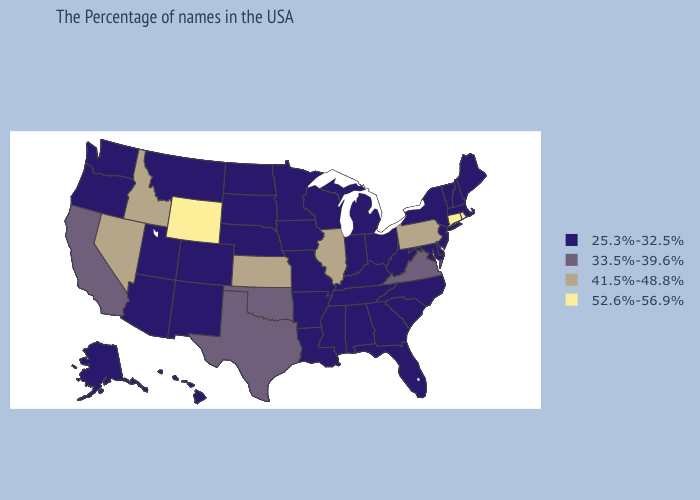Name the states that have a value in the range 25.3%-32.5%?
Give a very brief answer. Maine, Massachusetts, New Hampshire, Vermont, New York, New Jersey, Delaware, Maryland, North Carolina, South Carolina, West Virginia, Ohio, Florida, Georgia, Michigan, Kentucky, Indiana, Alabama, Tennessee, Wisconsin, Mississippi, Louisiana, Missouri, Arkansas, Minnesota, Iowa, Nebraska, South Dakota, North Dakota, Colorado, New Mexico, Utah, Montana, Arizona, Washington, Oregon, Alaska, Hawaii. Does Florida have the lowest value in the South?
Give a very brief answer. Yes. Does New Hampshire have a lower value than Minnesota?
Short answer required. No. Does Ohio have the same value as Illinois?
Keep it brief. No. What is the lowest value in states that border Rhode Island?
Quick response, please. 25.3%-32.5%. What is the lowest value in states that border Texas?
Quick response, please. 25.3%-32.5%. What is the value of Texas?
Concise answer only. 33.5%-39.6%. What is the lowest value in states that border Michigan?
Be succinct. 25.3%-32.5%. What is the value of Alaska?
Concise answer only. 25.3%-32.5%. Which states have the lowest value in the West?
Keep it brief. Colorado, New Mexico, Utah, Montana, Arizona, Washington, Oregon, Alaska, Hawaii. What is the highest value in the MidWest ?
Quick response, please. 41.5%-48.8%. Among the states that border Tennessee , which have the lowest value?
Give a very brief answer. North Carolina, Georgia, Kentucky, Alabama, Mississippi, Missouri, Arkansas. What is the value of Iowa?
Short answer required. 25.3%-32.5%. Does Illinois have the highest value in the USA?
Keep it brief. No. 